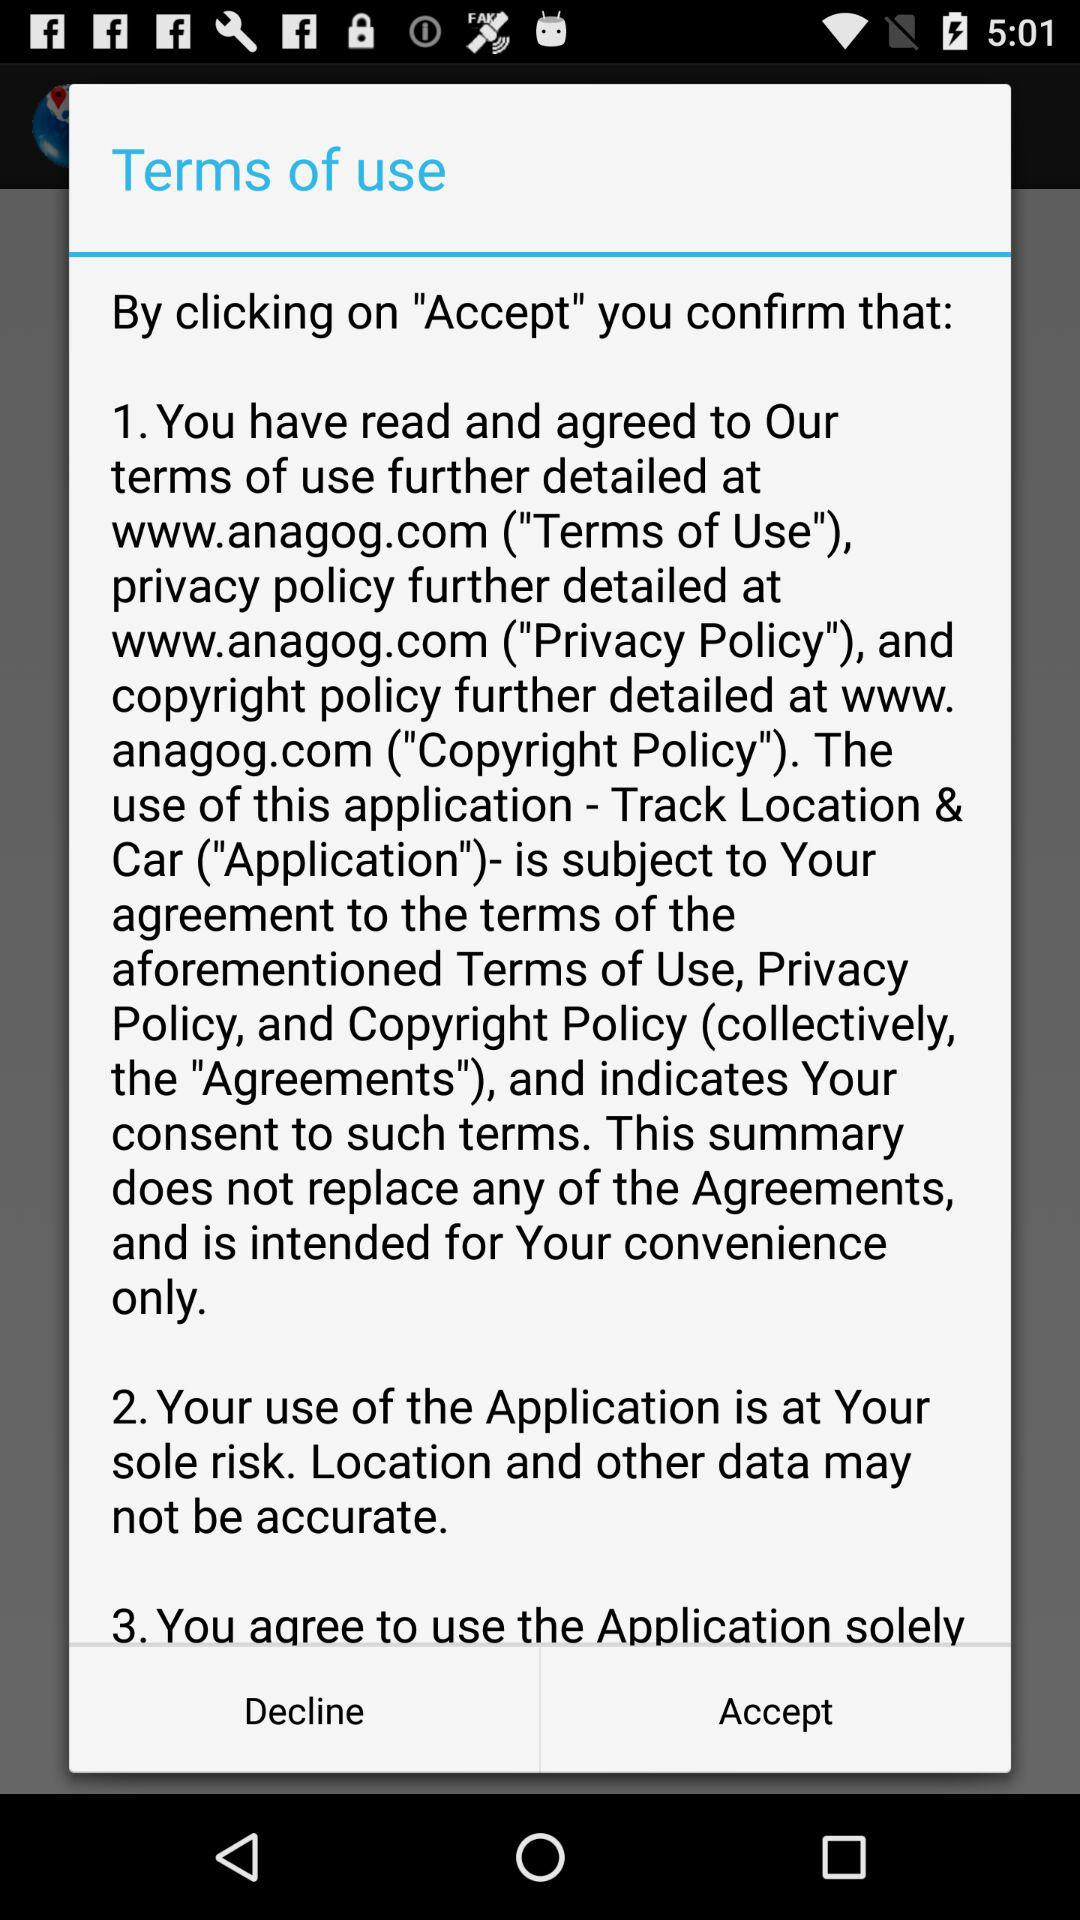How many terms of service must I agree to?
Answer the question using a single word or phrase. 3 